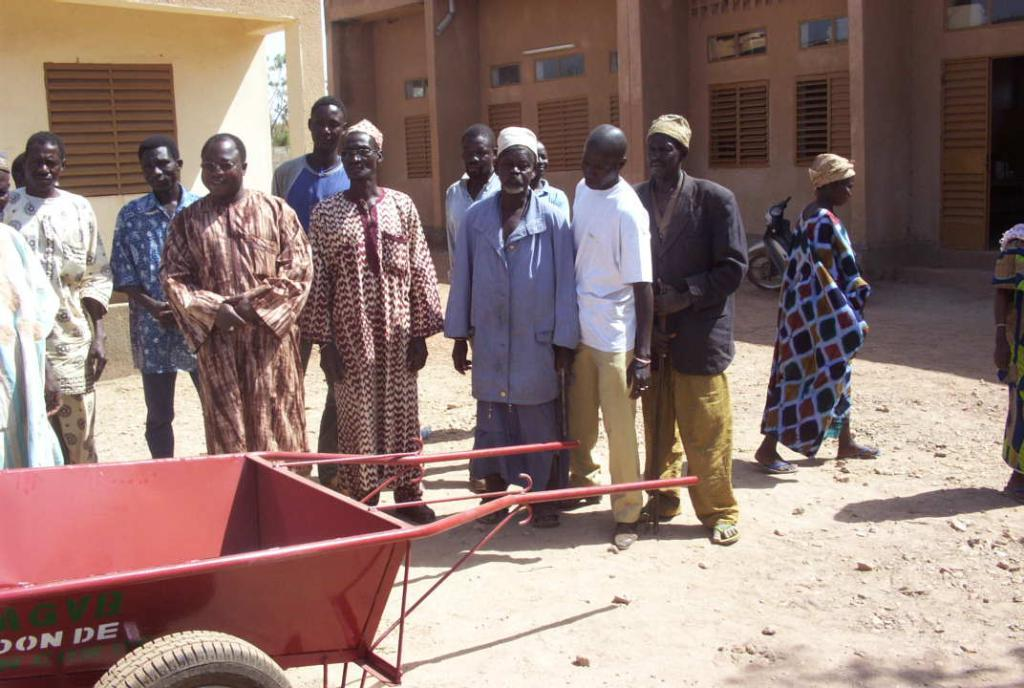How many people are in the image? There is a group of people in the image, but the exact number is not specified. What is in front of the group of people? There is a cart in front of the group of people. What can be seen in the distance behind the group of people? There are buildings and a motorcycle visible in the background of the image. Where is the playground located in the image? There is no playground present in the image. How many frogs are hopping around the motorcycle in the background? There are no frogs present in the image. 